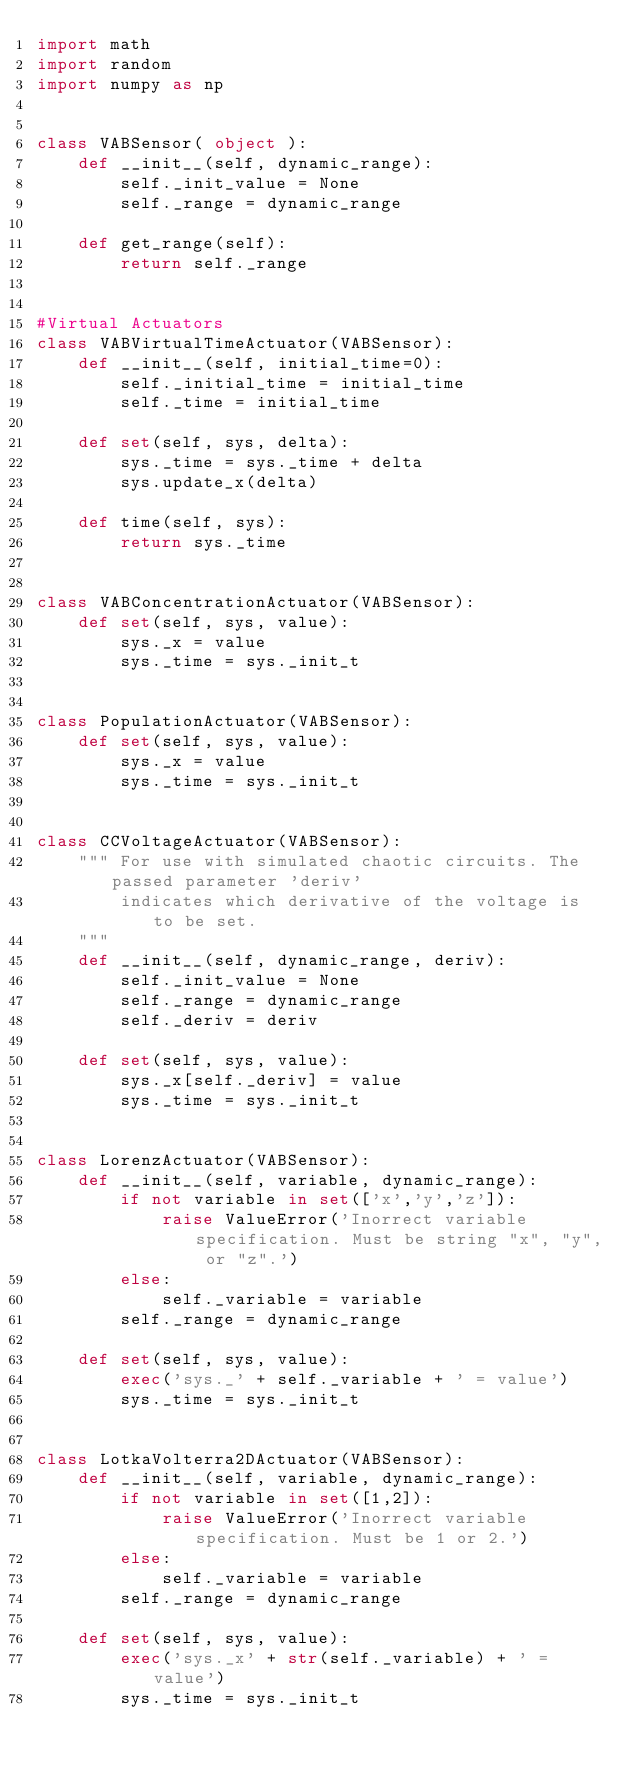<code> <loc_0><loc_0><loc_500><loc_500><_Python_>import math
import random
import numpy as np


class VABSensor( object ):
    def __init__(self, dynamic_range):
        self._init_value = None
        self._range = dynamic_range

    def get_range(self):
        return self._range


#Virtual Actuators
class VABVirtualTimeActuator(VABSensor):
    def __init__(self, initial_time=0):
        self._initial_time = initial_time
        self._time = initial_time

    def set(self, sys, delta):
        sys._time = sys._time + delta
        sys.update_x(delta)

    def time(self, sys):
        return sys._time
    

class VABConcentrationActuator(VABSensor):
    def set(self, sys, value):
        sys._x = value
        sys._time = sys._init_t


class PopulationActuator(VABSensor):
    def set(self, sys, value):
        sys._x = value
        sys._time = sys._init_t


class CCVoltageActuator(VABSensor):
    """ For use with simulated chaotic circuits. The passed parameter 'deriv'
        indicates which derivative of the voltage is to be set.
    """
    def __init__(self, dynamic_range, deriv):
        self._init_value = None
        self._range = dynamic_range   
        self._deriv = deriv

    def set(self, sys, value):
        sys._x[self._deriv] = value
        sys._time = sys._init_t    


class LorenzActuator(VABSensor):
    def __init__(self, variable, dynamic_range):
        if not variable in set(['x','y','z']):
            raise ValueError('Inorrect variable specification. Must be string "x", "y", or "z".')
        else:
            self._variable = variable
        self._range = dynamic_range
 
    def set(self, sys, value):
        exec('sys._' + self._variable + ' = value')
        sys._time = sys._init_t


class LotkaVolterra2DActuator(VABSensor):
    def __init__(self, variable, dynamic_range):
        if not variable in set([1,2]):
            raise ValueError('Inorrect variable specification. Must be 1 or 2.')
        else:
            self._variable = variable
        self._range = dynamic_range
 
    def set(self, sys, value):
        exec('sys._x' + str(self._variable) + ' = value')
        sys._time = sys._init_t
</code> 